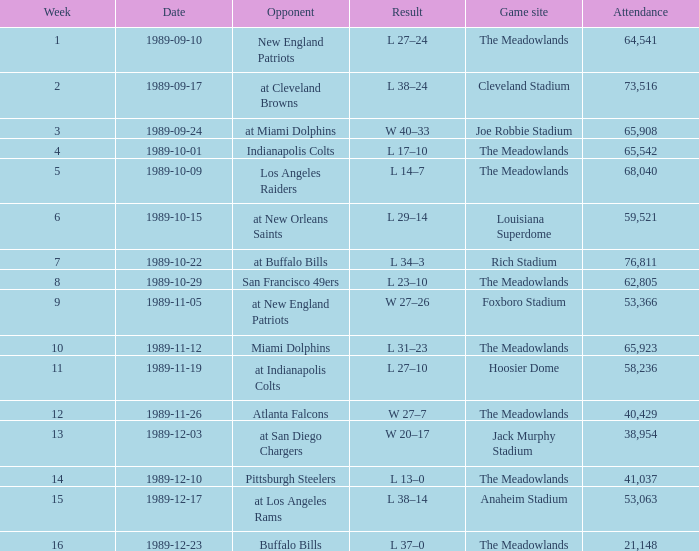What day did they participate before week 2? 1989-09-10. 